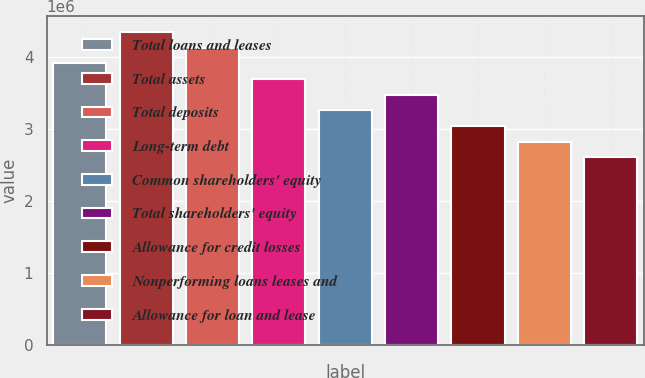<chart> <loc_0><loc_0><loc_500><loc_500><bar_chart><fcel>Total loans and leases<fcel>Total assets<fcel>Total deposits<fcel>Long-term debt<fcel>Common shareholders' equity<fcel>Total shareholders' equity<fcel>Allowance for credit losses<fcel>Nonperforming loans leases and<fcel>Allowance for loan and lease<nl><fcel>3.9052e+06<fcel>4.33911e+06<fcel>4.12215e+06<fcel>3.68824e+06<fcel>3.25433e+06<fcel>3.47129e+06<fcel>3.03738e+06<fcel>2.82042e+06<fcel>2.60347e+06<nl></chart> 